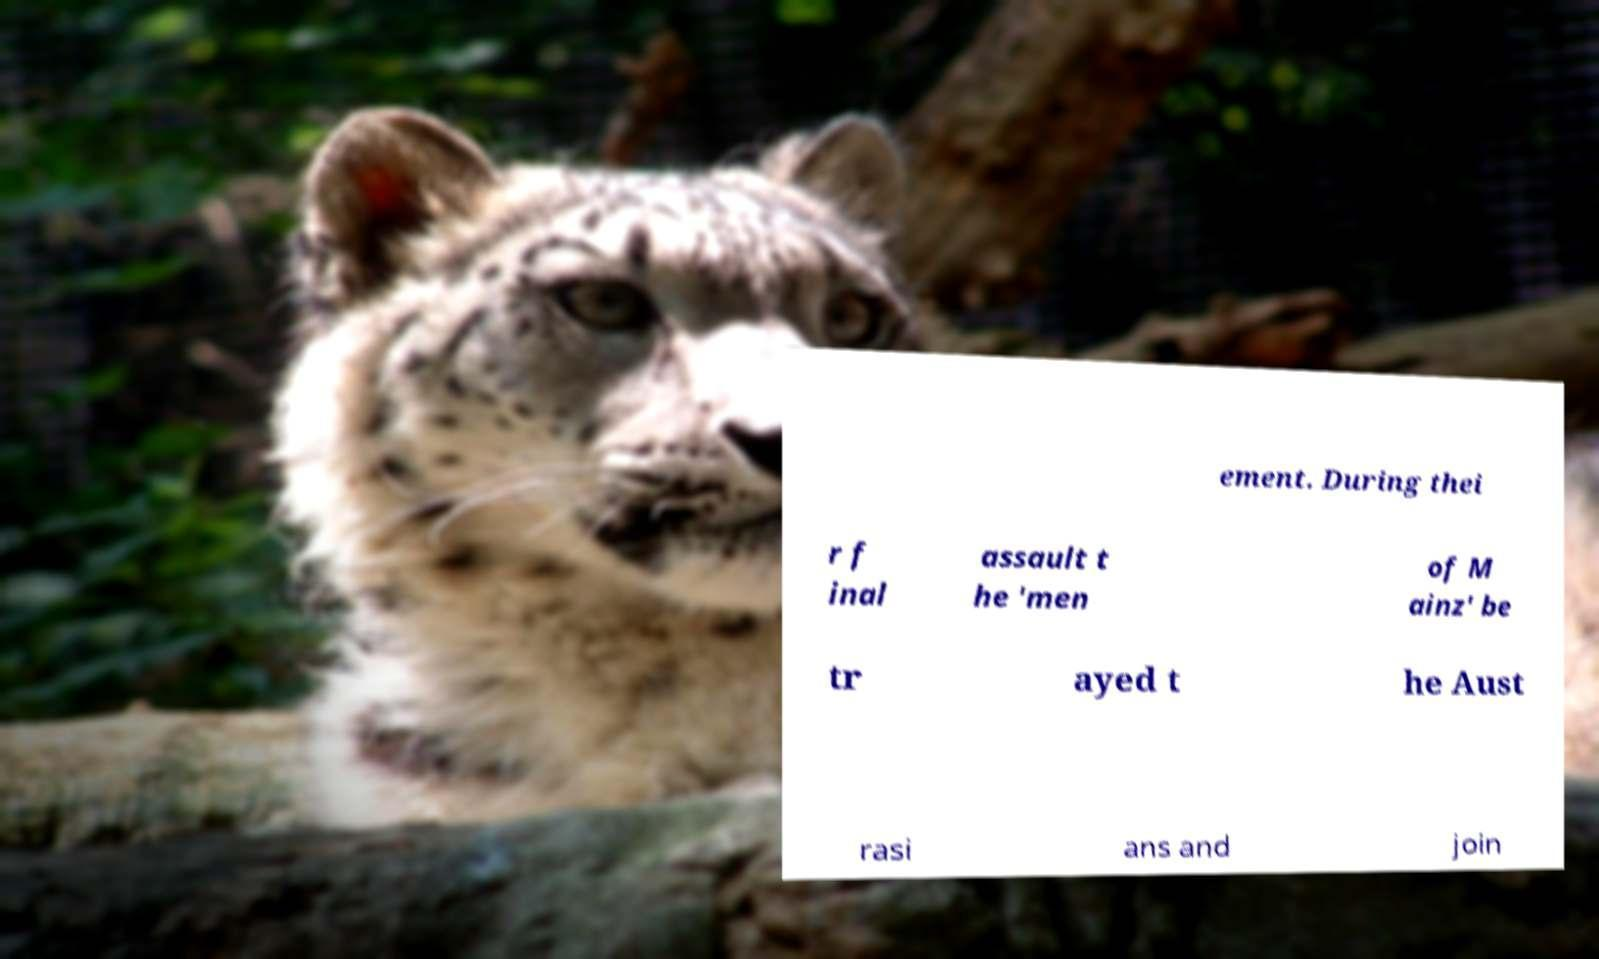Could you extract and type out the text from this image? ement. During thei r f inal assault t he 'men of M ainz' be tr ayed t he Aust rasi ans and join 